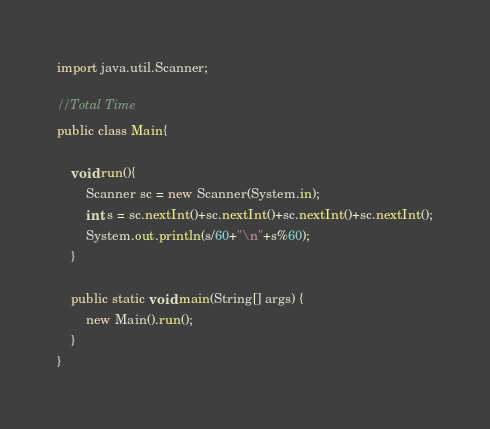Convert code to text. <code><loc_0><loc_0><loc_500><loc_500><_Java_>import java.util.Scanner;

//Total Time
public class Main{

	void run(){
		Scanner sc = new Scanner(System.in);
		int s = sc.nextInt()+sc.nextInt()+sc.nextInt()+sc.nextInt();
		System.out.println(s/60+"\n"+s%60);
	}
	
	public static void main(String[] args) {
		new Main().run();
	}
}</code> 